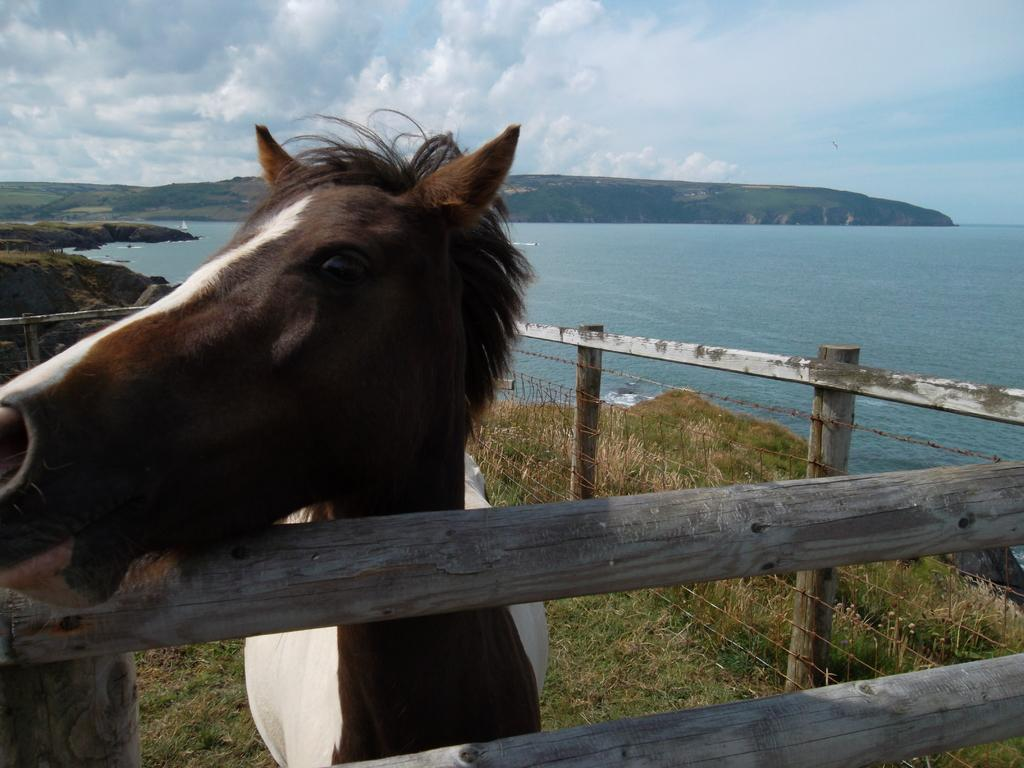What animal is inside the fencing in the image? There is a horse inside the fencing in the image. What type of landscape can be seen in the background of the image? There is a sea beside a hill in the background of the image. What is visible at the top of the image? The sky is visible at the top of the image. What type of apparatus is being used by the horse in the image? There is no apparatus being used by the horse in the image; it is simply standing inside the fencing. 